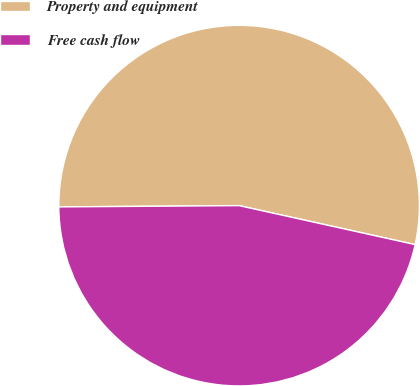Convert chart to OTSL. <chart><loc_0><loc_0><loc_500><loc_500><pie_chart><fcel>Property and equipment<fcel>Free cash flow<nl><fcel>53.58%<fcel>46.42%<nl></chart> 